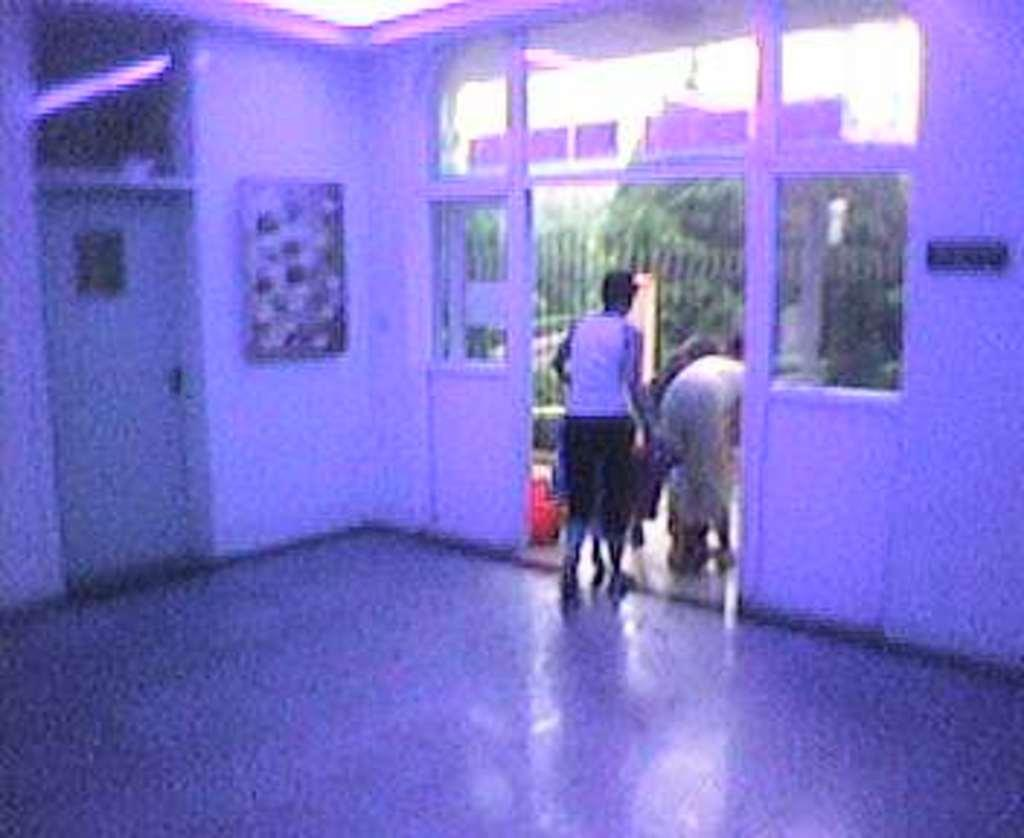What is the setting of the image? The image depicts the inside of a room. Are there any individuals present in the room? Yes, there are people in the room. How would you describe the quality of the image? The image is blurred. What part of the room can be seen in the image? The floor is visible in the image. What type of sound can be heard coming from the quartz in the image? There is no quartz present in the image, and therefore no sound can be heard from it. What is being served for breakfast in the image? The image does not depict any food or meal, so it cannot be determined what is being served for breakfast. 